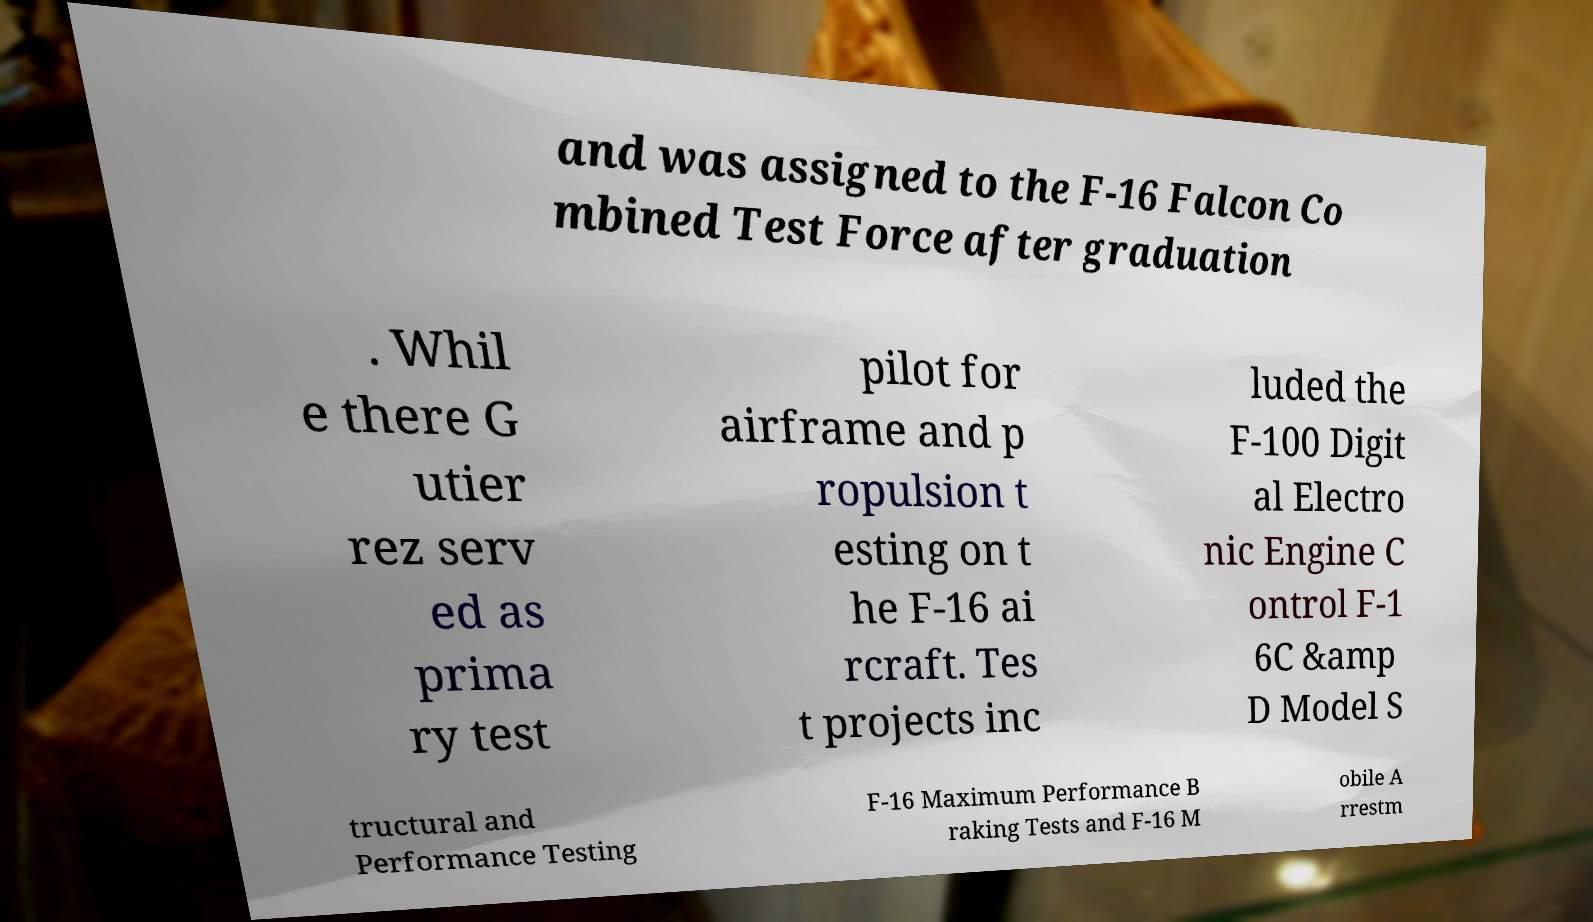Could you extract and type out the text from this image? and was assigned to the F-16 Falcon Co mbined Test Force after graduation . Whil e there G utier rez serv ed as prima ry test pilot for airframe and p ropulsion t esting on t he F-16 ai rcraft. Tes t projects inc luded the F-100 Digit al Electro nic Engine C ontrol F-1 6C &amp D Model S tructural and Performance Testing F-16 Maximum Performance B raking Tests and F-16 M obile A rrestm 